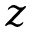<formula> <loc_0><loc_0><loc_500><loc_500>z</formula> 